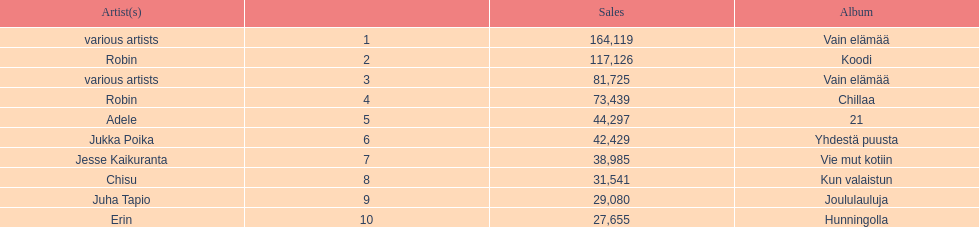Could you parse the entire table? {'header': ['Artist(s)', '', 'Sales', 'Album'], 'rows': [['various artists', '1', '164,119', 'Vain elämää'], ['Robin', '2', '117,126', 'Koodi'], ['various artists', '3', '81,725', 'Vain elämää'], ['Robin', '4', '73,439', 'Chillaa'], ['Adele', '5', '44,297', '21'], ['Jukka Poika', '6', '42,429', 'Yhdestä puusta'], ['Jesse Kaikuranta', '7', '38,985', 'Vie mut kotiin'], ['Chisu', '8', '31,541', 'Kun valaistun'], ['Juha Tapio', '9', '29,080', 'Joululauluja'], ['Erin', '10', '27,655', 'Hunningolla']]} How many albums sold for than 50,000 copies this year? 4. 